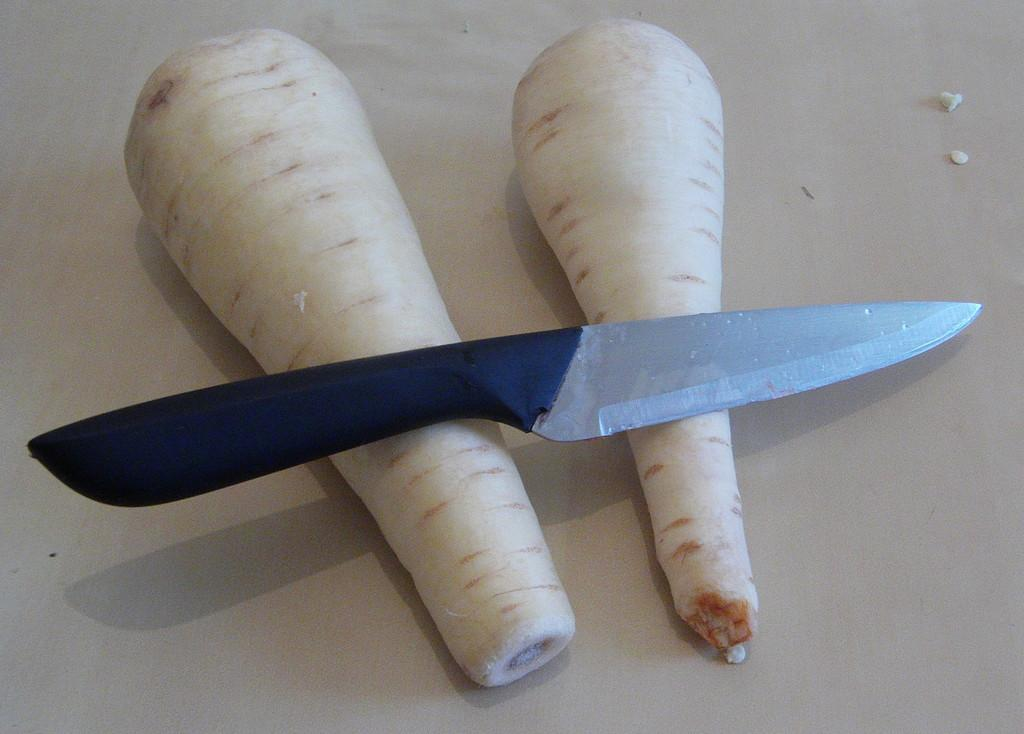What type of vegetables are present in the image? There are two radishes in the image. Where are the radishes located? The radishes are placed on a surface. What object is placed on the radishes? There is a knife in the image, and it is placed on the radishes. What is the color of the knife's handle? The knife has a black handle. How many cars are parked next to the radishes in the image? There are no cars present in the image; it only features radishes, a surface, and a knife. 